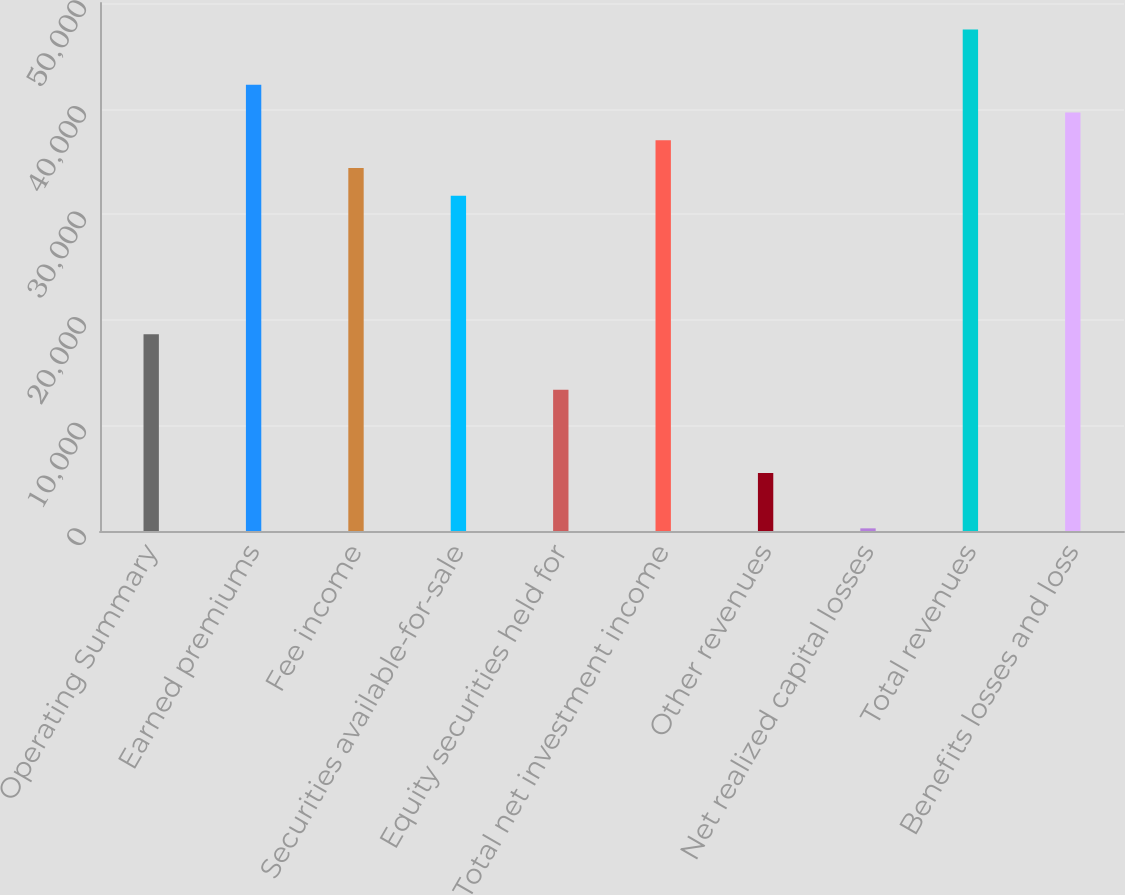<chart> <loc_0><loc_0><loc_500><loc_500><bar_chart><fcel>Operating Summary<fcel>Earned premiums<fcel>Fee income<fcel>Securities available-for-sale<fcel>Equity securities held for<fcel>Total net investment income<fcel>Other revenues<fcel>Net realized capital losses<fcel>Total revenues<fcel>Benefits losses and loss<nl><fcel>18625.3<fcel>42249.4<fcel>34374.7<fcel>31749.8<fcel>13375.5<fcel>36999.6<fcel>5500.8<fcel>251<fcel>47499.2<fcel>39624.5<nl></chart> 